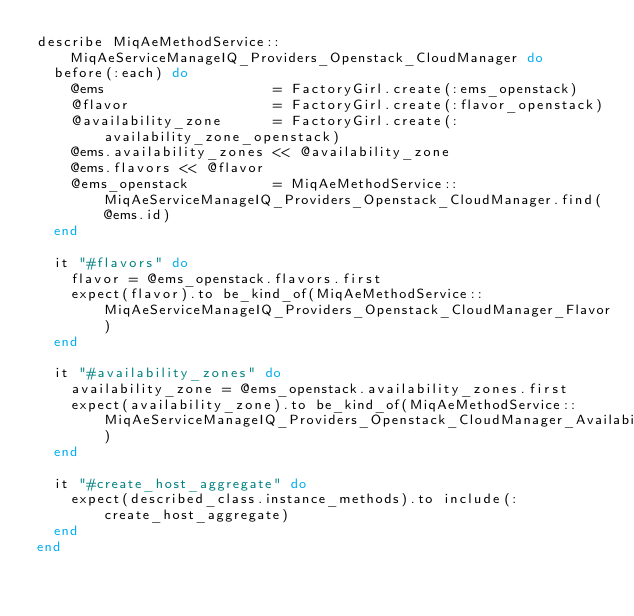<code> <loc_0><loc_0><loc_500><loc_500><_Ruby_>describe MiqAeMethodService::MiqAeServiceManageIQ_Providers_Openstack_CloudManager do
  before(:each) do
    @ems                    = FactoryGirl.create(:ems_openstack)
    @flavor                 = FactoryGirl.create(:flavor_openstack)
    @availability_zone      = FactoryGirl.create(:availability_zone_openstack)
    @ems.availability_zones << @availability_zone
    @ems.flavors << @flavor
    @ems_openstack          = MiqAeMethodService::MiqAeServiceManageIQ_Providers_Openstack_CloudManager.find(@ems.id)
  end

  it "#flavors" do
    flavor = @ems_openstack.flavors.first
    expect(flavor).to be_kind_of(MiqAeMethodService::MiqAeServiceManageIQ_Providers_Openstack_CloudManager_Flavor)
  end

  it "#availability_zones" do
    availability_zone = @ems_openstack.availability_zones.first
    expect(availability_zone).to be_kind_of(MiqAeMethodService::MiqAeServiceManageIQ_Providers_Openstack_CloudManager_AvailabilityZone)
  end

  it "#create_host_aggregate" do
    expect(described_class.instance_methods).to include(:create_host_aggregate)
  end
end
</code> 